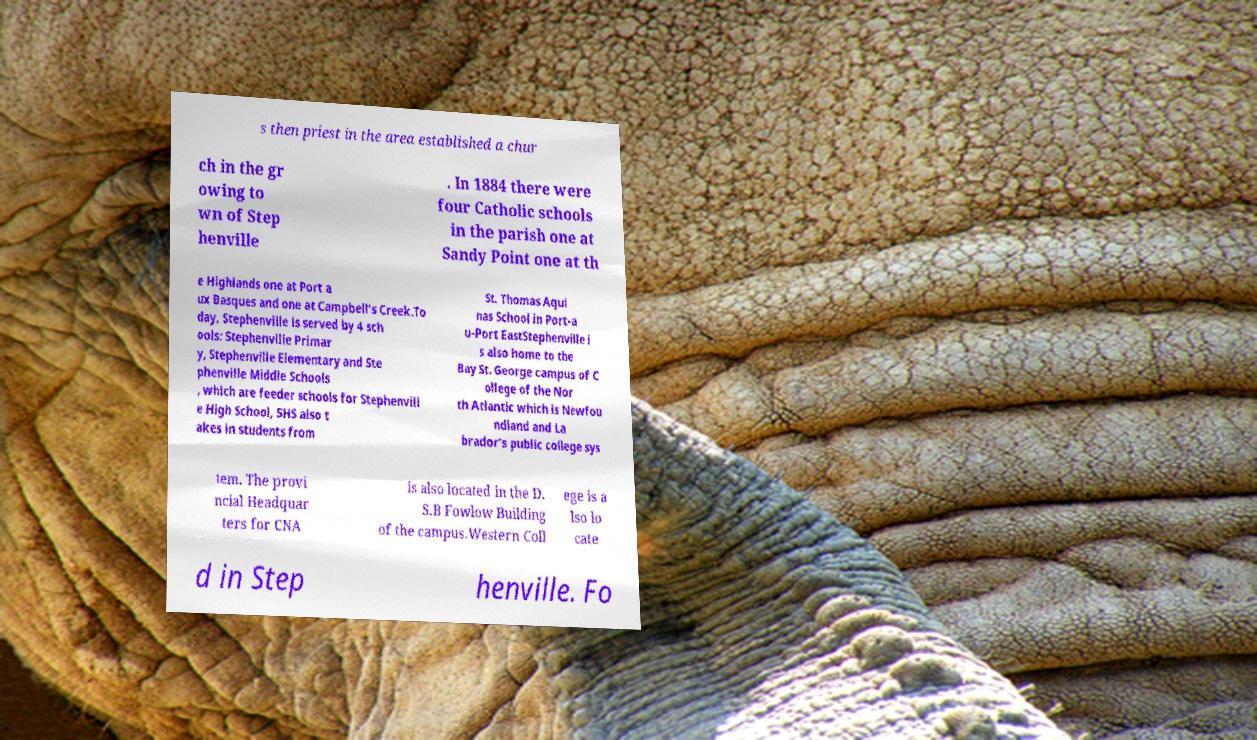Can you read and provide the text displayed in the image?This photo seems to have some interesting text. Can you extract and type it out for me? s then priest in the area established a chur ch in the gr owing to wn of Step henville . In 1884 there were four Catholic schools in the parish one at Sandy Point one at th e Highlands one at Port a ux Basques and one at Campbell's Creek.To day, Stephenville is served by 4 sch ools: Stephenville Primar y, Stephenville Elementary and Ste phenville Middle Schools , which are feeder schools for Stephenvill e High School, SHS also t akes in students from St. Thomas Aqui nas School in Port-a u-Port EastStephenville i s also home to the Bay St. George campus of C ollege of the Nor th Atlantic which is Newfou ndland and La brador's public college sys tem. The provi ncial Headquar ters for CNA is also located in the D. S.B Fowlow Building of the campus.Western Coll ege is a lso lo cate d in Step henville. Fo 